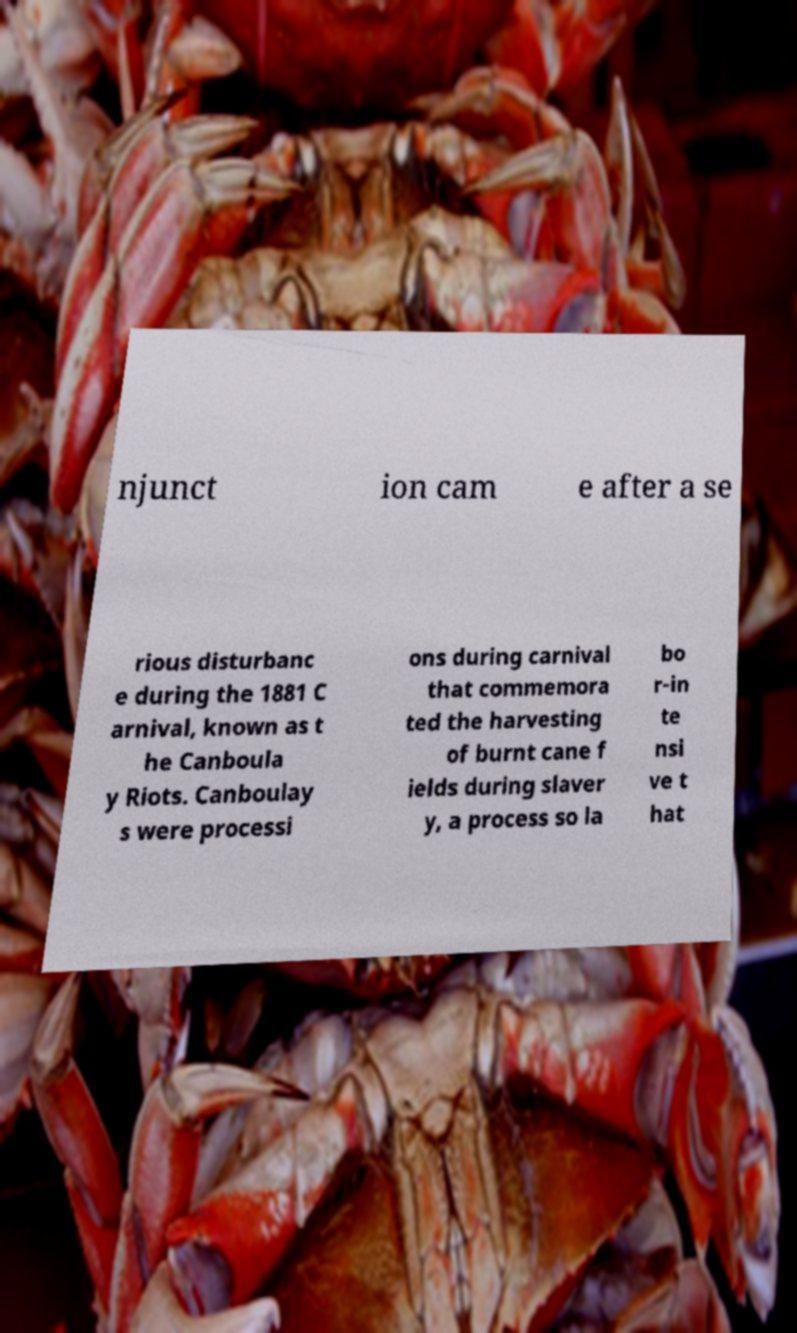Could you assist in decoding the text presented in this image and type it out clearly? njunct ion cam e after a se rious disturbanc e during the 1881 C arnival, known as t he Canboula y Riots. Canboulay s were processi ons during carnival that commemora ted the harvesting of burnt cane f ields during slaver y, a process so la bo r-in te nsi ve t hat 